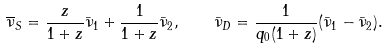Convert formula to latex. <formula><loc_0><loc_0><loc_500><loc_500>\overline { \nu } _ { S } = \frac { z } { 1 + z } \bar { \nu } _ { 1 } + \frac { 1 } { 1 + z } \bar { \nu } _ { 2 } , \quad \bar { \nu } _ { D } = \frac { 1 } { q _ { 0 } ( 1 + z ) } ( \bar { \nu } _ { 1 } - \bar { \nu } _ { 2 } ) .</formula> 